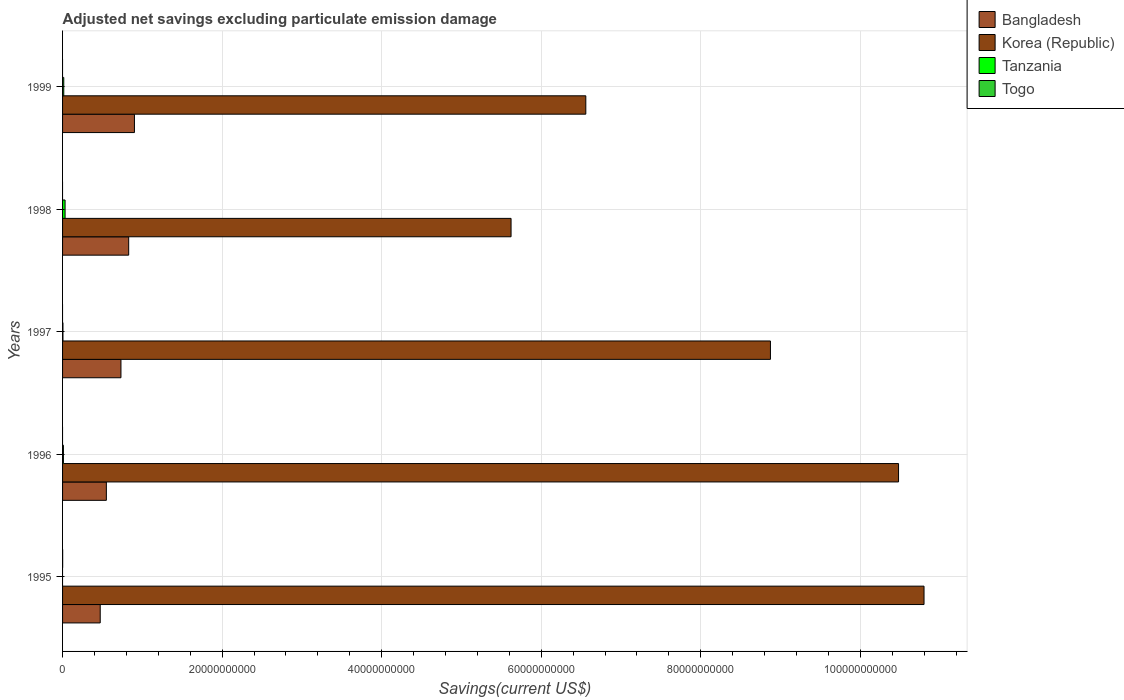How many different coloured bars are there?
Make the answer very short. 4. Are the number of bars per tick equal to the number of legend labels?
Provide a succinct answer. No. Are the number of bars on each tick of the Y-axis equal?
Ensure brevity in your answer.  Yes. How many bars are there on the 4th tick from the top?
Your answer should be very brief. 3. How many bars are there on the 5th tick from the bottom?
Give a very brief answer. 3. What is the adjusted net savings in Korea (Republic) in 1995?
Offer a terse response. 1.08e+11. Across all years, what is the maximum adjusted net savings in Togo?
Ensure brevity in your answer.  1.12e+07. Across all years, what is the minimum adjusted net savings in Bangladesh?
Your response must be concise. 4.72e+09. In which year was the adjusted net savings in Togo maximum?
Provide a short and direct response. 1995. What is the total adjusted net savings in Tanzania in the graph?
Provide a short and direct response. 6.20e+08. What is the difference between the adjusted net savings in Tanzania in 1997 and that in 1998?
Your answer should be compact. -2.67e+08. What is the difference between the adjusted net savings in Bangladesh in 1998 and the adjusted net savings in Tanzania in 1999?
Give a very brief answer. 8.14e+09. What is the average adjusted net savings in Togo per year?
Your answer should be very brief. 2.24e+06. In the year 1996, what is the difference between the adjusted net savings in Bangladesh and adjusted net savings in Tanzania?
Make the answer very short. 5.38e+09. What is the ratio of the adjusted net savings in Bangladesh in 1997 to that in 1998?
Make the answer very short. 0.88. Is the adjusted net savings in Korea (Republic) in 1995 less than that in 1996?
Provide a short and direct response. No. What is the difference between the highest and the second highest adjusted net savings in Tanzania?
Your answer should be compact. 1.66e+08. What is the difference between the highest and the lowest adjusted net savings in Tanzania?
Give a very brief answer. 3.16e+08. Is the sum of the adjusted net savings in Korea (Republic) in 1995 and 1996 greater than the maximum adjusted net savings in Bangladesh across all years?
Your answer should be very brief. Yes. Is it the case that in every year, the sum of the adjusted net savings in Togo and adjusted net savings in Tanzania is greater than the adjusted net savings in Korea (Republic)?
Offer a very short reply. No. How many bars are there?
Provide a short and direct response. 15. How many years are there in the graph?
Give a very brief answer. 5. How are the legend labels stacked?
Provide a succinct answer. Vertical. What is the title of the graph?
Provide a short and direct response. Adjusted net savings excluding particulate emission damage. Does "Antigua and Barbuda" appear as one of the legend labels in the graph?
Ensure brevity in your answer.  No. What is the label or title of the X-axis?
Your answer should be very brief. Savings(current US$). What is the Savings(current US$) in Bangladesh in 1995?
Your answer should be very brief. 4.72e+09. What is the Savings(current US$) of Korea (Republic) in 1995?
Your response must be concise. 1.08e+11. What is the Savings(current US$) of Togo in 1995?
Your response must be concise. 1.12e+07. What is the Savings(current US$) of Bangladesh in 1996?
Provide a short and direct response. 5.49e+09. What is the Savings(current US$) in Korea (Republic) in 1996?
Keep it short and to the point. 1.05e+11. What is the Savings(current US$) in Tanzania in 1996?
Your answer should be very brief. 1.06e+08. What is the Savings(current US$) in Bangladesh in 1997?
Ensure brevity in your answer.  7.32e+09. What is the Savings(current US$) of Korea (Republic) in 1997?
Keep it short and to the point. 8.87e+1. What is the Savings(current US$) in Tanzania in 1997?
Ensure brevity in your answer.  4.86e+07. What is the Savings(current US$) of Bangladesh in 1998?
Offer a terse response. 8.29e+09. What is the Savings(current US$) in Korea (Republic) in 1998?
Provide a short and direct response. 5.62e+1. What is the Savings(current US$) in Tanzania in 1998?
Give a very brief answer. 3.16e+08. What is the Savings(current US$) of Bangladesh in 1999?
Ensure brevity in your answer.  9.01e+09. What is the Savings(current US$) in Korea (Republic) in 1999?
Give a very brief answer. 6.56e+1. What is the Savings(current US$) of Tanzania in 1999?
Keep it short and to the point. 1.50e+08. What is the Savings(current US$) of Togo in 1999?
Keep it short and to the point. 0. Across all years, what is the maximum Savings(current US$) in Bangladesh?
Ensure brevity in your answer.  9.01e+09. Across all years, what is the maximum Savings(current US$) of Korea (Republic)?
Keep it short and to the point. 1.08e+11. Across all years, what is the maximum Savings(current US$) of Tanzania?
Your answer should be very brief. 3.16e+08. Across all years, what is the maximum Savings(current US$) of Togo?
Provide a short and direct response. 1.12e+07. Across all years, what is the minimum Savings(current US$) of Bangladesh?
Your response must be concise. 4.72e+09. Across all years, what is the minimum Savings(current US$) of Korea (Republic)?
Ensure brevity in your answer.  5.62e+1. What is the total Savings(current US$) in Bangladesh in the graph?
Your response must be concise. 3.48e+1. What is the total Savings(current US$) in Korea (Republic) in the graph?
Offer a very short reply. 4.23e+11. What is the total Savings(current US$) in Tanzania in the graph?
Give a very brief answer. 6.20e+08. What is the total Savings(current US$) of Togo in the graph?
Offer a terse response. 1.12e+07. What is the difference between the Savings(current US$) in Bangladesh in 1995 and that in 1996?
Your answer should be compact. -7.69e+08. What is the difference between the Savings(current US$) of Korea (Republic) in 1995 and that in 1996?
Provide a short and direct response. 3.20e+09. What is the difference between the Savings(current US$) of Bangladesh in 1995 and that in 1997?
Offer a terse response. -2.60e+09. What is the difference between the Savings(current US$) in Korea (Republic) in 1995 and that in 1997?
Keep it short and to the point. 1.93e+1. What is the difference between the Savings(current US$) in Bangladesh in 1995 and that in 1998?
Keep it short and to the point. -3.57e+09. What is the difference between the Savings(current US$) of Korea (Republic) in 1995 and that in 1998?
Your response must be concise. 5.18e+1. What is the difference between the Savings(current US$) in Bangladesh in 1995 and that in 1999?
Offer a very short reply. -4.29e+09. What is the difference between the Savings(current US$) of Korea (Republic) in 1995 and that in 1999?
Give a very brief answer. 4.24e+1. What is the difference between the Savings(current US$) in Bangladesh in 1996 and that in 1997?
Your response must be concise. -1.83e+09. What is the difference between the Savings(current US$) in Korea (Republic) in 1996 and that in 1997?
Your response must be concise. 1.61e+1. What is the difference between the Savings(current US$) in Tanzania in 1996 and that in 1997?
Your response must be concise. 5.78e+07. What is the difference between the Savings(current US$) of Bangladesh in 1996 and that in 1998?
Provide a succinct answer. -2.80e+09. What is the difference between the Savings(current US$) of Korea (Republic) in 1996 and that in 1998?
Offer a terse response. 4.86e+1. What is the difference between the Savings(current US$) of Tanzania in 1996 and that in 1998?
Provide a succinct answer. -2.09e+08. What is the difference between the Savings(current US$) of Bangladesh in 1996 and that in 1999?
Your answer should be very brief. -3.52e+09. What is the difference between the Savings(current US$) of Korea (Republic) in 1996 and that in 1999?
Keep it short and to the point. 3.92e+1. What is the difference between the Savings(current US$) in Tanzania in 1996 and that in 1999?
Offer a terse response. -4.34e+07. What is the difference between the Savings(current US$) in Bangladesh in 1997 and that in 1998?
Ensure brevity in your answer.  -9.70e+08. What is the difference between the Savings(current US$) in Korea (Republic) in 1997 and that in 1998?
Provide a succinct answer. 3.25e+1. What is the difference between the Savings(current US$) of Tanzania in 1997 and that in 1998?
Your answer should be compact. -2.67e+08. What is the difference between the Savings(current US$) of Bangladesh in 1997 and that in 1999?
Offer a very short reply. -1.69e+09. What is the difference between the Savings(current US$) of Korea (Republic) in 1997 and that in 1999?
Make the answer very short. 2.31e+1. What is the difference between the Savings(current US$) of Tanzania in 1997 and that in 1999?
Your answer should be very brief. -1.01e+08. What is the difference between the Savings(current US$) in Bangladesh in 1998 and that in 1999?
Ensure brevity in your answer.  -7.21e+08. What is the difference between the Savings(current US$) in Korea (Republic) in 1998 and that in 1999?
Your answer should be compact. -9.37e+09. What is the difference between the Savings(current US$) in Tanzania in 1998 and that in 1999?
Make the answer very short. 1.66e+08. What is the difference between the Savings(current US$) of Bangladesh in 1995 and the Savings(current US$) of Korea (Republic) in 1996?
Provide a short and direct response. -1.00e+11. What is the difference between the Savings(current US$) in Bangladesh in 1995 and the Savings(current US$) in Tanzania in 1996?
Make the answer very short. 4.61e+09. What is the difference between the Savings(current US$) of Korea (Republic) in 1995 and the Savings(current US$) of Tanzania in 1996?
Keep it short and to the point. 1.08e+11. What is the difference between the Savings(current US$) of Bangladesh in 1995 and the Savings(current US$) of Korea (Republic) in 1997?
Give a very brief answer. -8.40e+1. What is the difference between the Savings(current US$) in Bangladesh in 1995 and the Savings(current US$) in Tanzania in 1997?
Offer a terse response. 4.67e+09. What is the difference between the Savings(current US$) of Korea (Republic) in 1995 and the Savings(current US$) of Tanzania in 1997?
Your answer should be very brief. 1.08e+11. What is the difference between the Savings(current US$) of Bangladesh in 1995 and the Savings(current US$) of Korea (Republic) in 1998?
Provide a succinct answer. -5.15e+1. What is the difference between the Savings(current US$) of Bangladesh in 1995 and the Savings(current US$) of Tanzania in 1998?
Provide a short and direct response. 4.41e+09. What is the difference between the Savings(current US$) in Korea (Republic) in 1995 and the Savings(current US$) in Tanzania in 1998?
Give a very brief answer. 1.08e+11. What is the difference between the Savings(current US$) of Bangladesh in 1995 and the Savings(current US$) of Korea (Republic) in 1999?
Make the answer very short. -6.09e+1. What is the difference between the Savings(current US$) of Bangladesh in 1995 and the Savings(current US$) of Tanzania in 1999?
Provide a short and direct response. 4.57e+09. What is the difference between the Savings(current US$) of Korea (Republic) in 1995 and the Savings(current US$) of Tanzania in 1999?
Your answer should be very brief. 1.08e+11. What is the difference between the Savings(current US$) in Bangladesh in 1996 and the Savings(current US$) in Korea (Republic) in 1997?
Keep it short and to the point. -8.32e+1. What is the difference between the Savings(current US$) of Bangladesh in 1996 and the Savings(current US$) of Tanzania in 1997?
Your answer should be compact. 5.44e+09. What is the difference between the Savings(current US$) of Korea (Republic) in 1996 and the Savings(current US$) of Tanzania in 1997?
Make the answer very short. 1.05e+11. What is the difference between the Savings(current US$) in Bangladesh in 1996 and the Savings(current US$) in Korea (Republic) in 1998?
Give a very brief answer. -5.07e+1. What is the difference between the Savings(current US$) in Bangladesh in 1996 and the Savings(current US$) in Tanzania in 1998?
Keep it short and to the point. 5.17e+09. What is the difference between the Savings(current US$) of Korea (Republic) in 1996 and the Savings(current US$) of Tanzania in 1998?
Your response must be concise. 1.04e+11. What is the difference between the Savings(current US$) in Bangladesh in 1996 and the Savings(current US$) in Korea (Republic) in 1999?
Your response must be concise. -6.01e+1. What is the difference between the Savings(current US$) of Bangladesh in 1996 and the Savings(current US$) of Tanzania in 1999?
Ensure brevity in your answer.  5.34e+09. What is the difference between the Savings(current US$) of Korea (Republic) in 1996 and the Savings(current US$) of Tanzania in 1999?
Make the answer very short. 1.05e+11. What is the difference between the Savings(current US$) of Bangladesh in 1997 and the Savings(current US$) of Korea (Republic) in 1998?
Your answer should be very brief. -4.89e+1. What is the difference between the Savings(current US$) in Bangladesh in 1997 and the Savings(current US$) in Tanzania in 1998?
Ensure brevity in your answer.  7.00e+09. What is the difference between the Savings(current US$) of Korea (Republic) in 1997 and the Savings(current US$) of Tanzania in 1998?
Make the answer very short. 8.84e+1. What is the difference between the Savings(current US$) in Bangladesh in 1997 and the Savings(current US$) in Korea (Republic) in 1999?
Provide a succinct answer. -5.83e+1. What is the difference between the Savings(current US$) in Bangladesh in 1997 and the Savings(current US$) in Tanzania in 1999?
Ensure brevity in your answer.  7.17e+09. What is the difference between the Savings(current US$) of Korea (Republic) in 1997 and the Savings(current US$) of Tanzania in 1999?
Keep it short and to the point. 8.86e+1. What is the difference between the Savings(current US$) of Bangladesh in 1998 and the Savings(current US$) of Korea (Republic) in 1999?
Keep it short and to the point. -5.73e+1. What is the difference between the Savings(current US$) in Bangladesh in 1998 and the Savings(current US$) in Tanzania in 1999?
Your response must be concise. 8.14e+09. What is the difference between the Savings(current US$) of Korea (Republic) in 1998 and the Savings(current US$) of Tanzania in 1999?
Provide a short and direct response. 5.61e+1. What is the average Savings(current US$) of Bangladesh per year?
Your response must be concise. 6.97e+09. What is the average Savings(current US$) of Korea (Republic) per year?
Make the answer very short. 8.47e+1. What is the average Savings(current US$) in Tanzania per year?
Your answer should be very brief. 1.24e+08. What is the average Savings(current US$) of Togo per year?
Give a very brief answer. 2.24e+06. In the year 1995, what is the difference between the Savings(current US$) of Bangladesh and Savings(current US$) of Korea (Republic)?
Provide a short and direct response. -1.03e+11. In the year 1995, what is the difference between the Savings(current US$) in Bangladesh and Savings(current US$) in Togo?
Keep it short and to the point. 4.71e+09. In the year 1995, what is the difference between the Savings(current US$) in Korea (Republic) and Savings(current US$) in Togo?
Provide a short and direct response. 1.08e+11. In the year 1996, what is the difference between the Savings(current US$) of Bangladesh and Savings(current US$) of Korea (Republic)?
Offer a very short reply. -9.93e+1. In the year 1996, what is the difference between the Savings(current US$) in Bangladesh and Savings(current US$) in Tanzania?
Offer a very short reply. 5.38e+09. In the year 1996, what is the difference between the Savings(current US$) of Korea (Republic) and Savings(current US$) of Tanzania?
Offer a very short reply. 1.05e+11. In the year 1997, what is the difference between the Savings(current US$) of Bangladesh and Savings(current US$) of Korea (Republic)?
Offer a very short reply. -8.14e+1. In the year 1997, what is the difference between the Savings(current US$) of Bangladesh and Savings(current US$) of Tanzania?
Your response must be concise. 7.27e+09. In the year 1997, what is the difference between the Savings(current US$) of Korea (Republic) and Savings(current US$) of Tanzania?
Your response must be concise. 8.87e+1. In the year 1998, what is the difference between the Savings(current US$) in Bangladesh and Savings(current US$) in Korea (Republic)?
Offer a very short reply. -4.79e+1. In the year 1998, what is the difference between the Savings(current US$) of Bangladesh and Savings(current US$) of Tanzania?
Offer a terse response. 7.97e+09. In the year 1998, what is the difference between the Savings(current US$) in Korea (Republic) and Savings(current US$) in Tanzania?
Provide a short and direct response. 5.59e+1. In the year 1999, what is the difference between the Savings(current US$) in Bangladesh and Savings(current US$) in Korea (Republic)?
Your answer should be very brief. -5.66e+1. In the year 1999, what is the difference between the Savings(current US$) in Bangladesh and Savings(current US$) in Tanzania?
Provide a short and direct response. 8.86e+09. In the year 1999, what is the difference between the Savings(current US$) of Korea (Republic) and Savings(current US$) of Tanzania?
Ensure brevity in your answer.  6.54e+1. What is the ratio of the Savings(current US$) of Bangladesh in 1995 to that in 1996?
Provide a succinct answer. 0.86. What is the ratio of the Savings(current US$) in Korea (Republic) in 1995 to that in 1996?
Your answer should be very brief. 1.03. What is the ratio of the Savings(current US$) in Bangladesh in 1995 to that in 1997?
Offer a terse response. 0.65. What is the ratio of the Savings(current US$) in Korea (Republic) in 1995 to that in 1997?
Ensure brevity in your answer.  1.22. What is the ratio of the Savings(current US$) in Bangladesh in 1995 to that in 1998?
Give a very brief answer. 0.57. What is the ratio of the Savings(current US$) in Korea (Republic) in 1995 to that in 1998?
Make the answer very short. 1.92. What is the ratio of the Savings(current US$) in Bangladesh in 1995 to that in 1999?
Make the answer very short. 0.52. What is the ratio of the Savings(current US$) of Korea (Republic) in 1995 to that in 1999?
Give a very brief answer. 1.65. What is the ratio of the Savings(current US$) of Bangladesh in 1996 to that in 1997?
Make the answer very short. 0.75. What is the ratio of the Savings(current US$) of Korea (Republic) in 1996 to that in 1997?
Keep it short and to the point. 1.18. What is the ratio of the Savings(current US$) in Tanzania in 1996 to that in 1997?
Provide a short and direct response. 2.19. What is the ratio of the Savings(current US$) of Bangladesh in 1996 to that in 1998?
Give a very brief answer. 0.66. What is the ratio of the Savings(current US$) of Korea (Republic) in 1996 to that in 1998?
Provide a succinct answer. 1.86. What is the ratio of the Savings(current US$) in Tanzania in 1996 to that in 1998?
Give a very brief answer. 0.34. What is the ratio of the Savings(current US$) of Bangladesh in 1996 to that in 1999?
Your response must be concise. 0.61. What is the ratio of the Savings(current US$) in Korea (Republic) in 1996 to that in 1999?
Your response must be concise. 1.6. What is the ratio of the Savings(current US$) of Tanzania in 1996 to that in 1999?
Ensure brevity in your answer.  0.71. What is the ratio of the Savings(current US$) of Bangladesh in 1997 to that in 1998?
Provide a short and direct response. 0.88. What is the ratio of the Savings(current US$) of Korea (Republic) in 1997 to that in 1998?
Give a very brief answer. 1.58. What is the ratio of the Savings(current US$) of Tanzania in 1997 to that in 1998?
Your answer should be very brief. 0.15. What is the ratio of the Savings(current US$) of Bangladesh in 1997 to that in 1999?
Your response must be concise. 0.81. What is the ratio of the Savings(current US$) of Korea (Republic) in 1997 to that in 1999?
Make the answer very short. 1.35. What is the ratio of the Savings(current US$) of Tanzania in 1997 to that in 1999?
Offer a terse response. 0.32. What is the ratio of the Savings(current US$) in Bangladesh in 1998 to that in 1999?
Provide a short and direct response. 0.92. What is the ratio of the Savings(current US$) in Korea (Republic) in 1998 to that in 1999?
Your response must be concise. 0.86. What is the ratio of the Savings(current US$) in Tanzania in 1998 to that in 1999?
Provide a short and direct response. 2.11. What is the difference between the highest and the second highest Savings(current US$) of Bangladesh?
Offer a terse response. 7.21e+08. What is the difference between the highest and the second highest Savings(current US$) of Korea (Republic)?
Ensure brevity in your answer.  3.20e+09. What is the difference between the highest and the second highest Savings(current US$) in Tanzania?
Provide a succinct answer. 1.66e+08. What is the difference between the highest and the lowest Savings(current US$) of Bangladesh?
Offer a terse response. 4.29e+09. What is the difference between the highest and the lowest Savings(current US$) of Korea (Republic)?
Keep it short and to the point. 5.18e+1. What is the difference between the highest and the lowest Savings(current US$) in Tanzania?
Ensure brevity in your answer.  3.16e+08. What is the difference between the highest and the lowest Savings(current US$) in Togo?
Provide a short and direct response. 1.12e+07. 